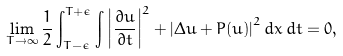<formula> <loc_0><loc_0><loc_500><loc_500>\lim _ { T \to \infty } \frac { 1 } { 2 } \int _ { T - \epsilon } ^ { T + \epsilon } \int \left | \frac { \partial u } { \partial t } \right | ^ { 2 } + \left | \Delta u + P ( u ) \right | ^ { 2 } d x \, d t = 0 ,</formula> 